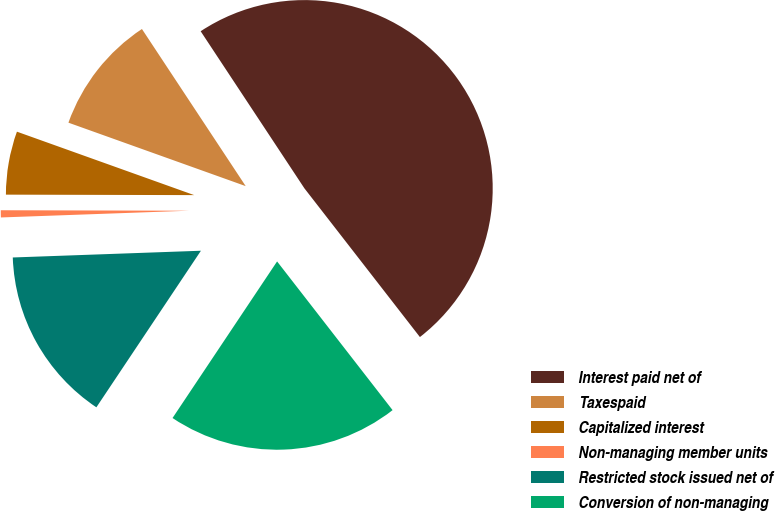Convert chart. <chart><loc_0><loc_0><loc_500><loc_500><pie_chart><fcel>Interest paid net of<fcel>Taxespaid<fcel>Capitalized interest<fcel>Non-managing member units<fcel>Restricted stock issued net of<fcel>Conversion of non-managing<nl><fcel>48.78%<fcel>10.24%<fcel>5.43%<fcel>0.61%<fcel>15.06%<fcel>19.88%<nl></chart> 